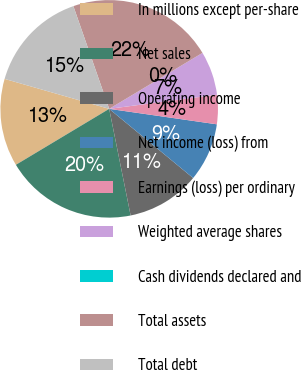Convert chart to OTSL. <chart><loc_0><loc_0><loc_500><loc_500><pie_chart><fcel>In millions except per-share<fcel>Net sales<fcel>Operating income<fcel>Net income (loss) from<fcel>Earnings (loss) per ordinary<fcel>Weighted average shares<fcel>Cash dividends declared and<fcel>Total assets<fcel>Total debt<nl><fcel>13.04%<fcel>19.56%<fcel>10.87%<fcel>8.7%<fcel>4.35%<fcel>6.52%<fcel>0.0%<fcel>21.74%<fcel>15.22%<nl></chart> 